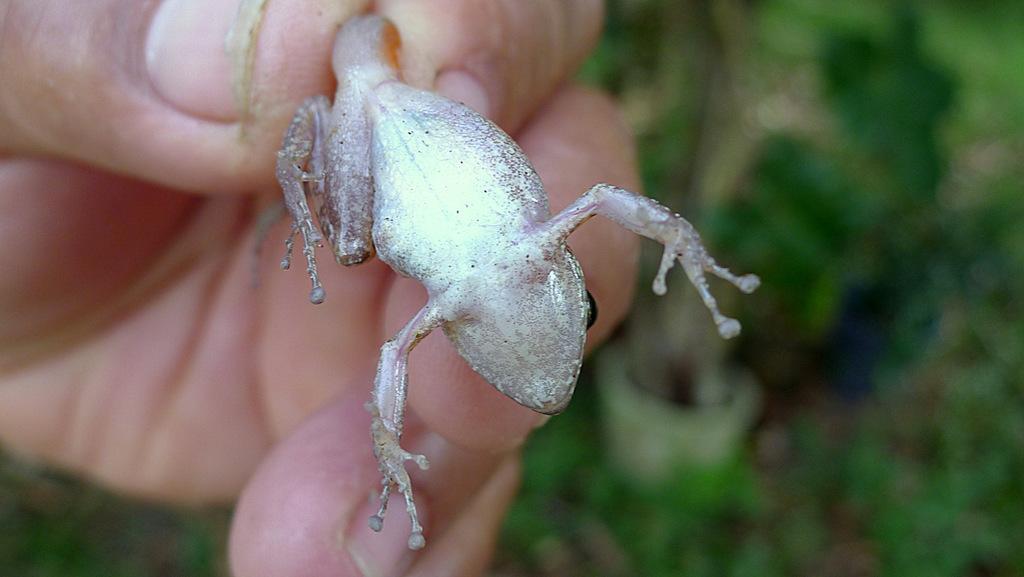In one or two sentences, can you explain what this image depicts? A human hand is holding the frog, it is in silver color. 